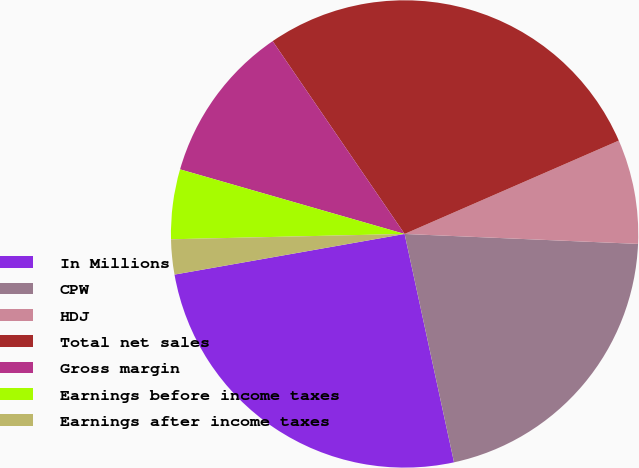Convert chart. <chart><loc_0><loc_0><loc_500><loc_500><pie_chart><fcel>In Millions<fcel>CPW<fcel>HDJ<fcel>Total net sales<fcel>Gross margin<fcel>Earnings before income taxes<fcel>Earnings after income taxes<nl><fcel>25.61%<fcel>20.93%<fcel>7.22%<fcel>28.01%<fcel>10.99%<fcel>4.82%<fcel>2.42%<nl></chart> 